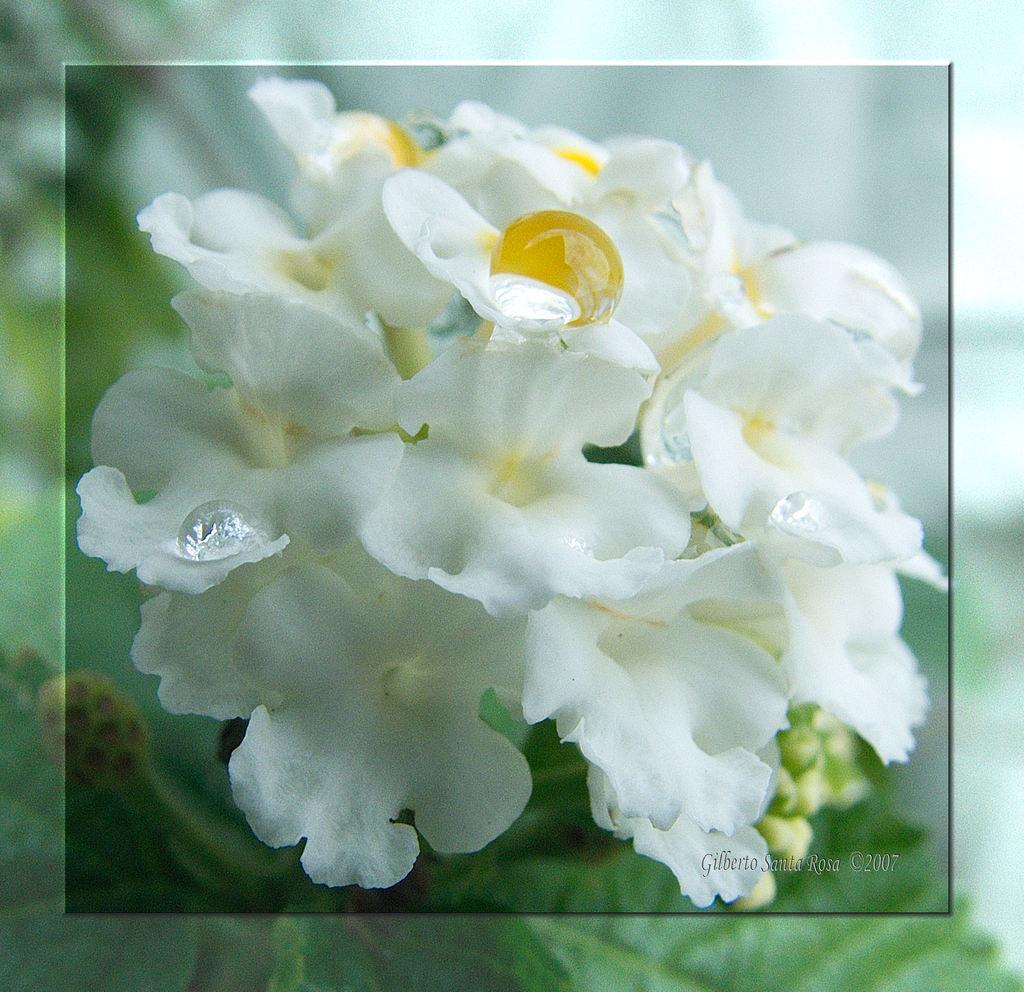What is the main subject of the image? There is a bunch of flowers in the image. What color are the flowers? The flowers are white in color. Is there any text or marking at the bottom of the image? Yes, there is a watermark at the bottom of the image. How would you describe the background of the image? The background of the image is blurry. Can you see any hills in the background of the image? There are no hills visible in the background of the image; it is blurry and does not show any specific landscape features. 